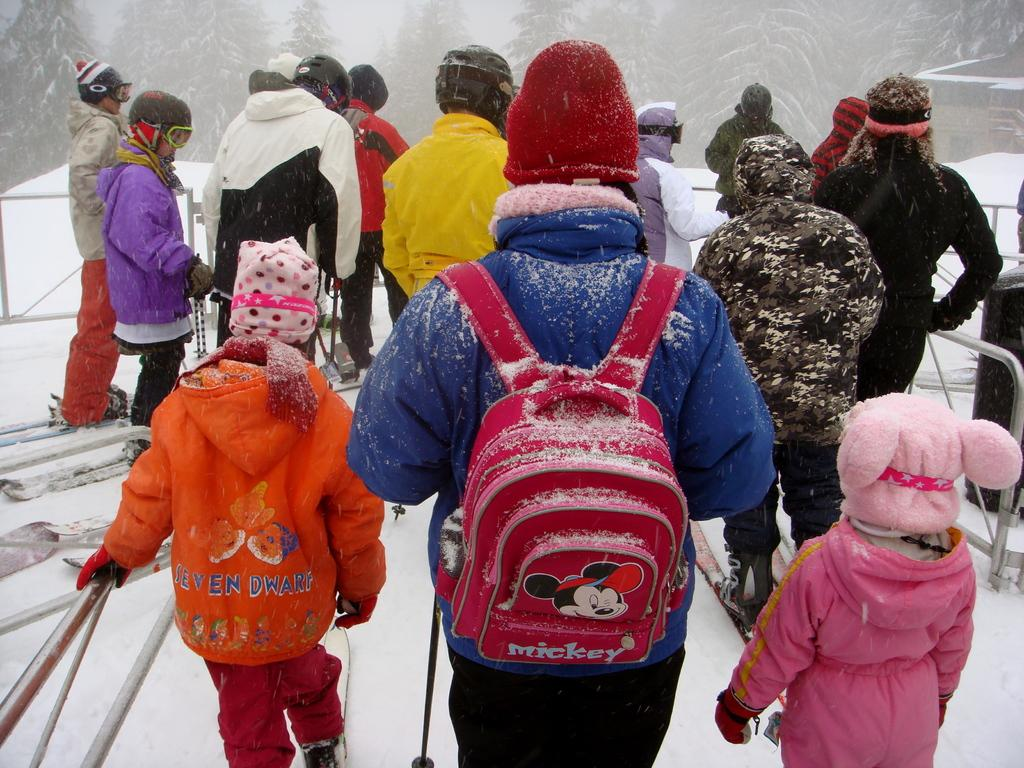What is the main subject of the image? The main subject of the image is a group of people. What are the people holding in the image? The people are holding ski poles in the image. What type of equipment are the people using for skiing? The people have skiboards in the image. What is the terrain like in the image? There is snow in the image, suggesting a winter or skiing environment. What can be seen in the background of the image? There are trees in the background of the image. What type of operation is being performed by the hen in the image? There is no hen present in the image; it features a group of people skiing. How does the addition of a new number affect the sum in the image? There is no mathematical equation or addition of numbers present in the image. 